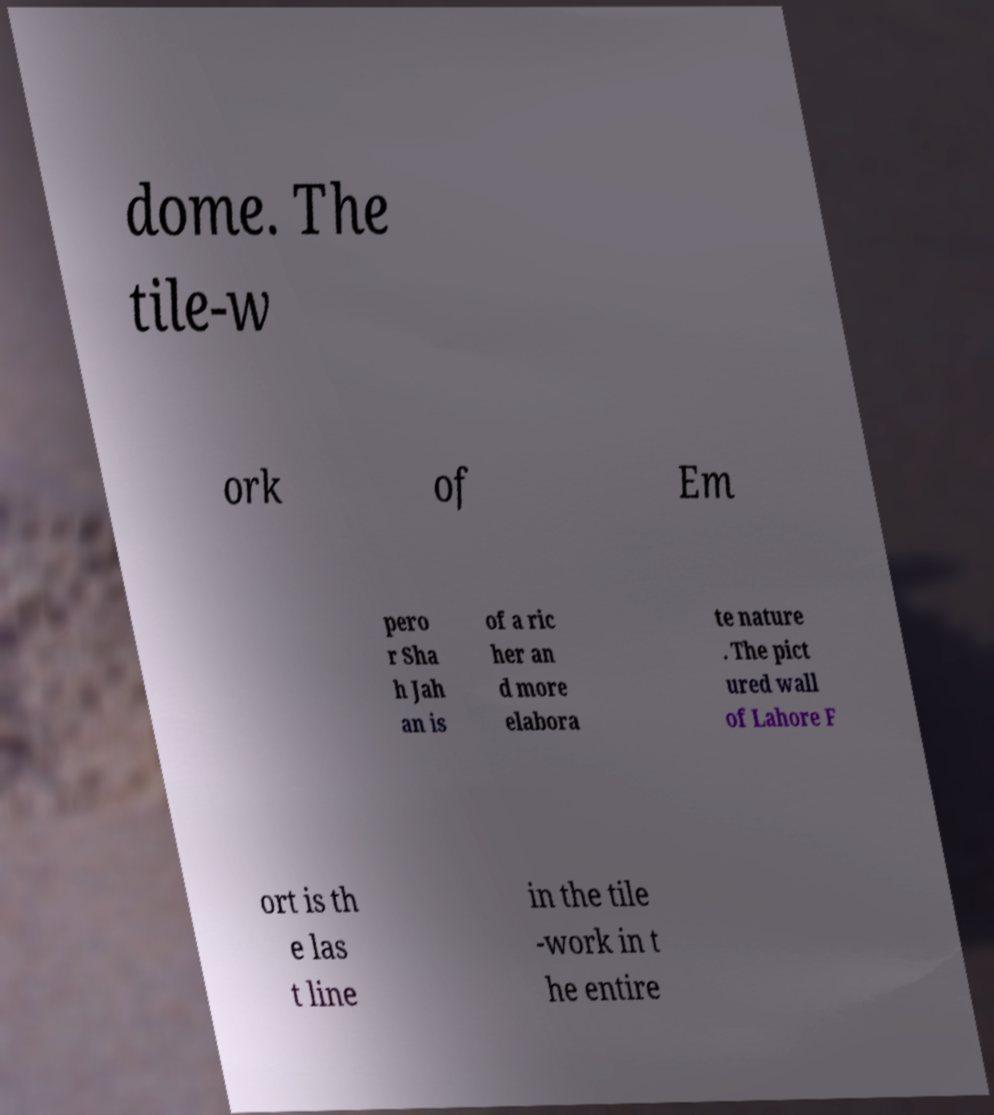For documentation purposes, I need the text within this image transcribed. Could you provide that? dome. The tile-w ork of Em pero r Sha h Jah an is of a ric her an d more elabora te nature . The pict ured wall of Lahore F ort is th e las t line in the tile -work in t he entire 